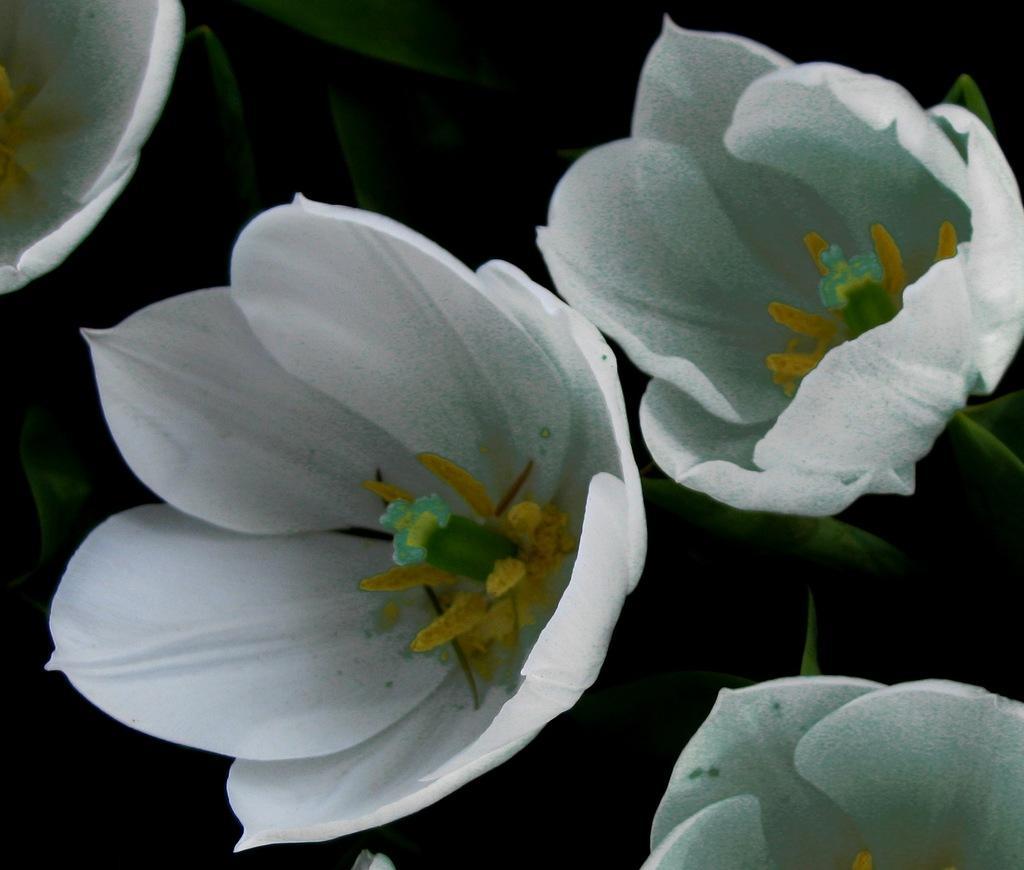Could you give a brief overview of what you see in this image? In the picture I can see white color flowers. 